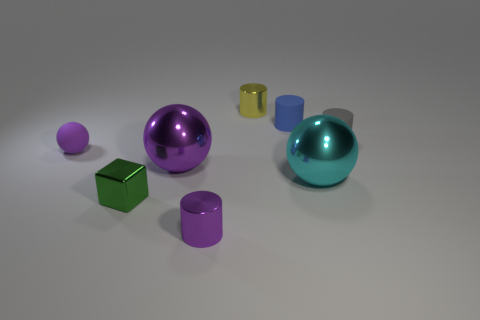What's the texture of the objects and what might their placement signify? The objects have a smooth, reflective surface, indicating they may be made of materials like plastic or metal. Their deliberate arrangement might represent an abstract composition or depict a study in perspective and light. 